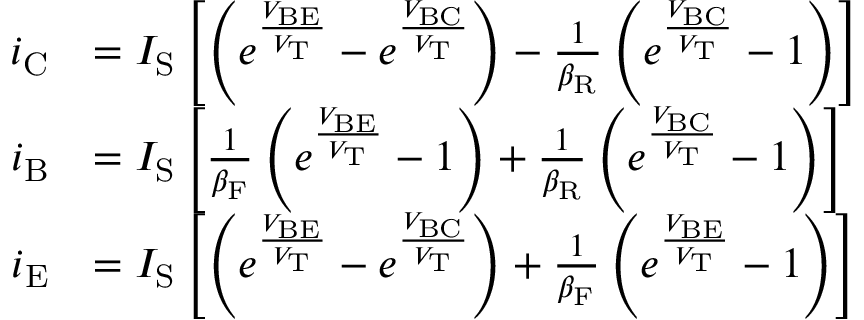<formula> <loc_0><loc_0><loc_500><loc_500>{ \begin{array} { r l } { i _ { C } } & { = I _ { S } \left [ \left ( e ^ { \frac { V _ { B E } } { V _ { T } } } - e ^ { \frac { V _ { B C } } { V _ { T } } } \right ) - { \frac { 1 } { \beta _ { R } } } \left ( e ^ { \frac { V _ { B C } } { V _ { T } } } - 1 \right ) \right ] } \\ { i _ { B } } & { = I _ { S } \left [ { \frac { 1 } { \beta _ { F } } } \left ( e ^ { \frac { V _ { B E } } { V _ { T } } } - 1 \right ) + { \frac { 1 } { \beta _ { R } } } \left ( e ^ { \frac { V _ { B C } } { V _ { T } } } - 1 \right ) \right ] } \\ { i _ { E } } & { = I _ { S } \left [ \left ( e ^ { \frac { V _ { B E } } { V _ { T } } } - e ^ { \frac { V _ { B C } } { V _ { T } } } \right ) + { \frac { 1 } { \beta _ { F } } } \left ( e ^ { \frac { V _ { B E } } { V _ { T } } } - 1 \right ) \right ] } \end{array} }</formula> 